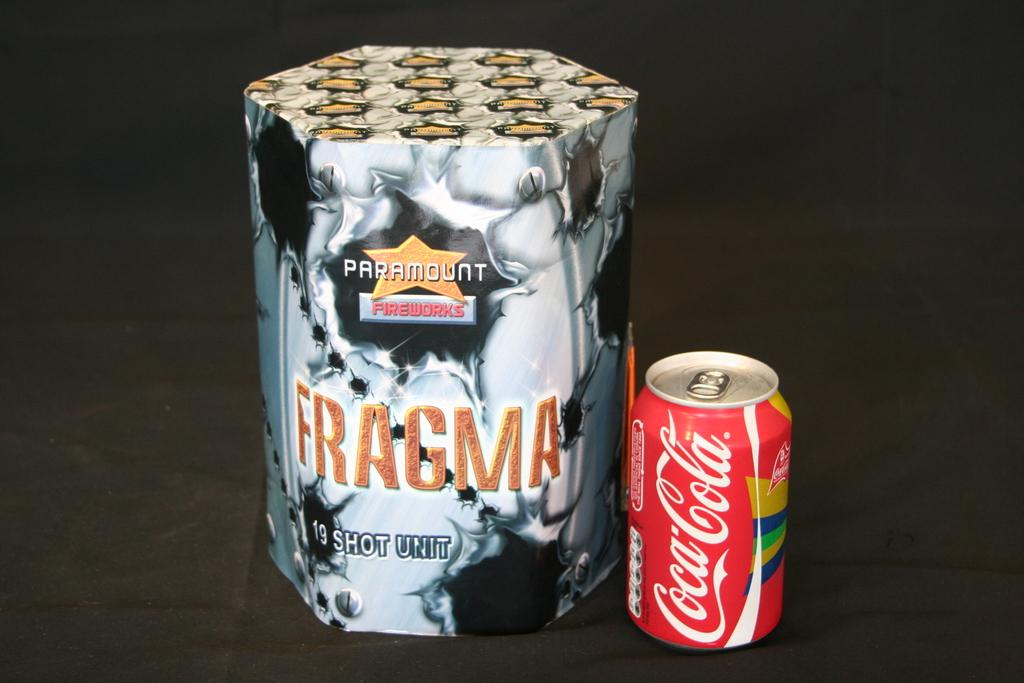<image>
Write a terse but informative summary of the picture. A can of Coca-Cola sits next to a box containing Fragma fireworks. 